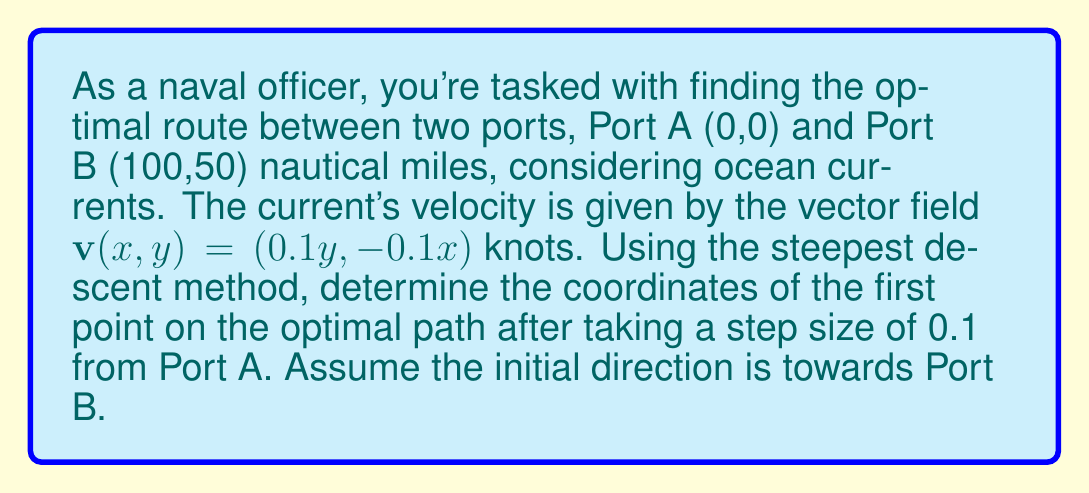Solve this math problem. 1) First, we need to define our objective function. In this case, we want to minimize the travel time. The travel time is given by the line integral:

   $$T = \int_C \frac{ds}{|\mathbf{u} + \mathbf{v}|}$$

   where $\mathbf{u}$ is the ship's velocity vector and $\mathbf{v}$ is the current velocity.

2) The gradient of this function at any point $(x,y)$ can be approximated as:

   $$\nabla T \approx \left(\frac{\partial T}{\partial x}, \frac{\partial T}{\partial y}\right) = \left(\frac{-v_x}{|\mathbf{u} + \mathbf{v}|^2}, \frac{-v_y}{|\mathbf{u} + \mathbf{v}|^2}\right)$$

3) The initial direction from Port A to Port B is:

   $$\mathbf{d} = (100, 50) / \sqrt{100^2 + 50^2} \approx (0.8944, 0.4472)$$

4) Assuming the ship's speed is 10 knots, the initial ship velocity is:

   $$\mathbf{u} = 10 \cdot (0.8944, 0.4472) = (8.944, 4.472)$$

5) At Port A (0,0), the current velocity is:

   $$\mathbf{v}(0,0) = (0.1 \cdot 0, -0.1 \cdot 0) = (0, 0)$$

6) The gradient at Port A is thus:

   $$\nabla T \approx (0, 0)$$

7) The steepest descent method updates the position by:

   $$\mathbf{x}_{n+1} = \mathbf{x}_n - \alpha \nabla T(\mathbf{x}_n)$$

   where $\alpha$ is the step size.

8) With $\alpha = 0.1$ and $\mathbf{x}_0 = (0, 0)$, the first point is:

   $$\mathbf{x}_1 = (0, 0) - 0.1 \cdot (0, 0) = (0, 0)$$

9) Since the gradient is zero, we move in the initial direction:

   $$\mathbf{x}_1 = (0, 0) + 0.1 \cdot (0.8944, 0.4472) = (0.08944, 0.04472)$$
Answer: (0.08944, 0.04472) 